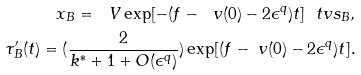Convert formula to latex. <formula><loc_0><loc_0><loc_500><loc_500>x _ { B } = \ V \exp [ - ( f - \ v ( 0 ) - 2 \epsilon ^ { q } ) t ] \ t v s _ { B } , \\ \tau _ { B } ^ { \prime } ( t ) = ( \frac { 2 } { k ^ { * } + 1 + O ( \epsilon ^ { q } ) } ) \exp [ ( f - \ v ( 0 ) - 2 \epsilon ^ { q } ) t ] .</formula> 